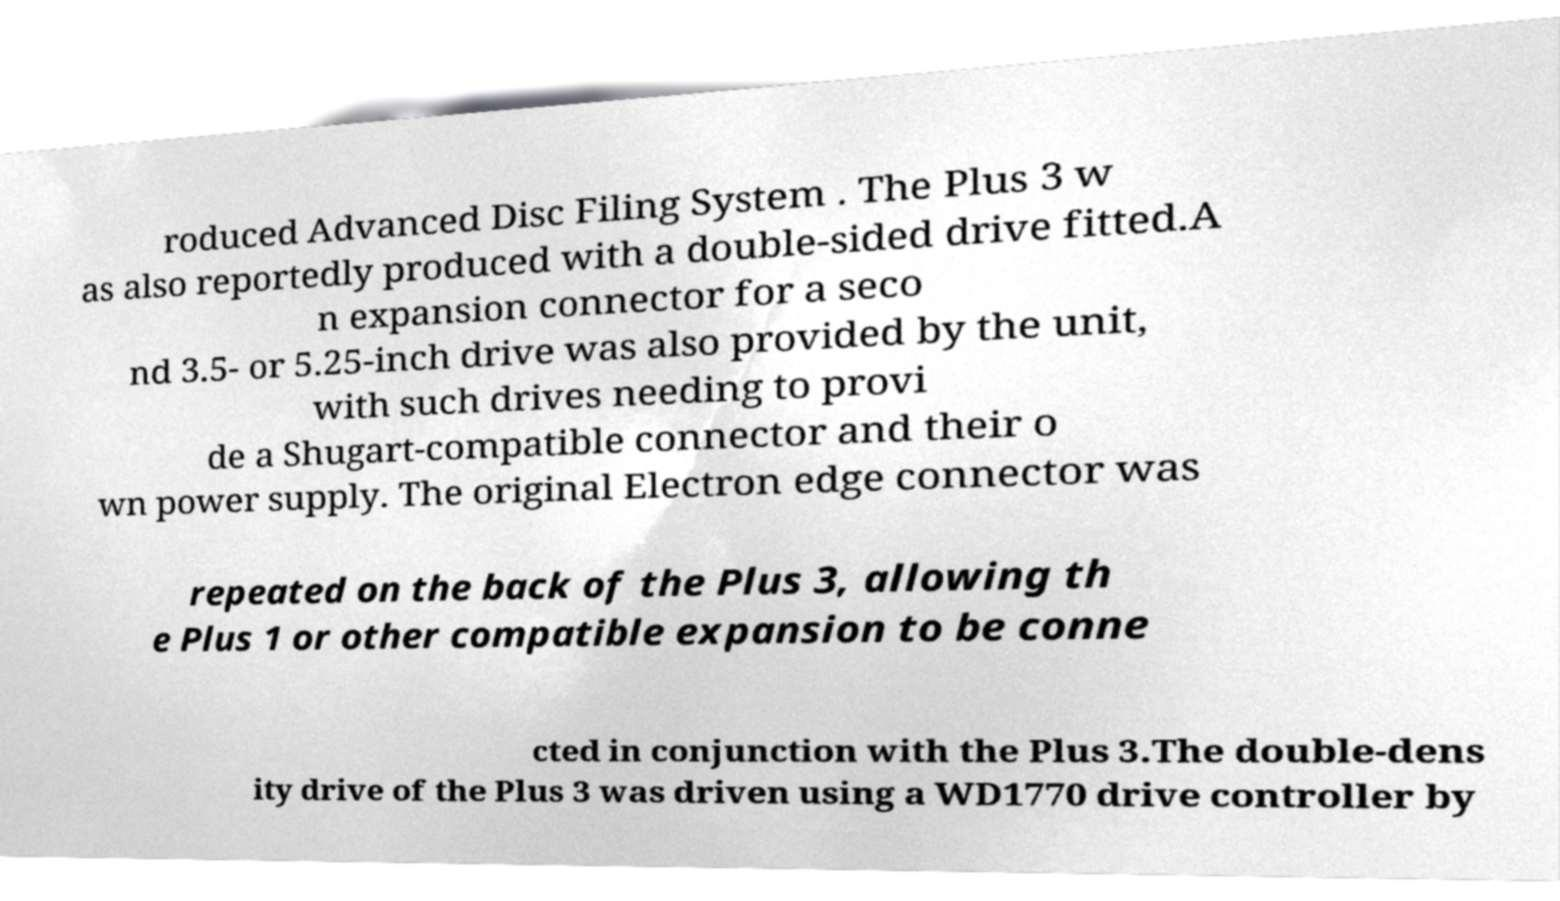What messages or text are displayed in this image? I need them in a readable, typed format. roduced Advanced Disc Filing System . The Plus 3 w as also reportedly produced with a double-sided drive fitted.A n expansion connector for a seco nd 3.5- or 5.25-inch drive was also provided by the unit, with such drives needing to provi de a Shugart-compatible connector and their o wn power supply. The original Electron edge connector was repeated on the back of the Plus 3, allowing th e Plus 1 or other compatible expansion to be conne cted in conjunction with the Plus 3.The double-dens ity drive of the Plus 3 was driven using a WD1770 drive controller by 